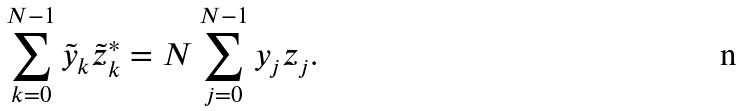<formula> <loc_0><loc_0><loc_500><loc_500>\sum _ { k = 0 } ^ { N - 1 } \tilde { y } _ { k } \tilde { z } ^ { * } _ { k } = N \sum _ { j = 0 } ^ { N - 1 } y _ { j } z _ { j } .</formula> 